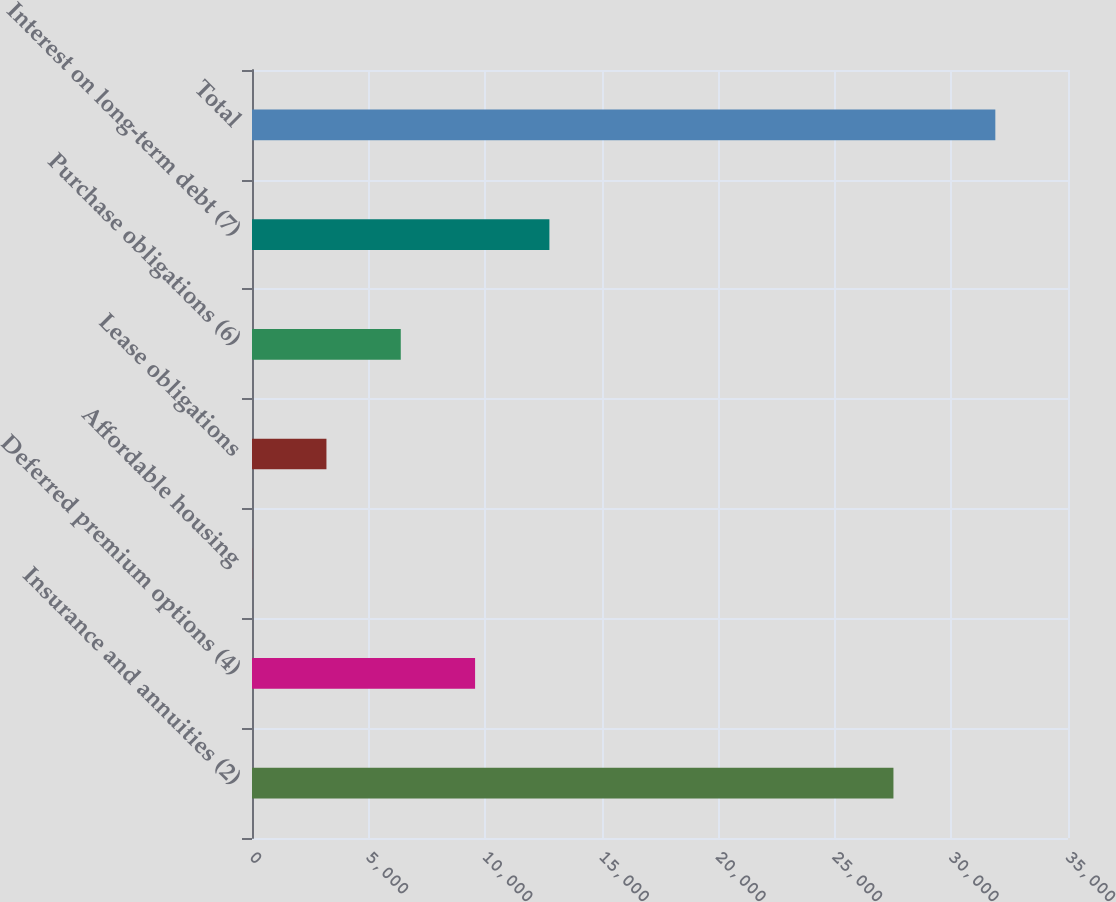<chart> <loc_0><loc_0><loc_500><loc_500><bar_chart><fcel>Insurance and annuities (2)<fcel>Deferred premium options (4)<fcel>Affordable housing<fcel>Lease obligations<fcel>Purchase obligations (6)<fcel>Interest on long-term debt (7)<fcel>Total<nl><fcel>27513<fcel>9568.4<fcel>5<fcel>3192.8<fcel>6380.6<fcel>12756.2<fcel>31883<nl></chart> 